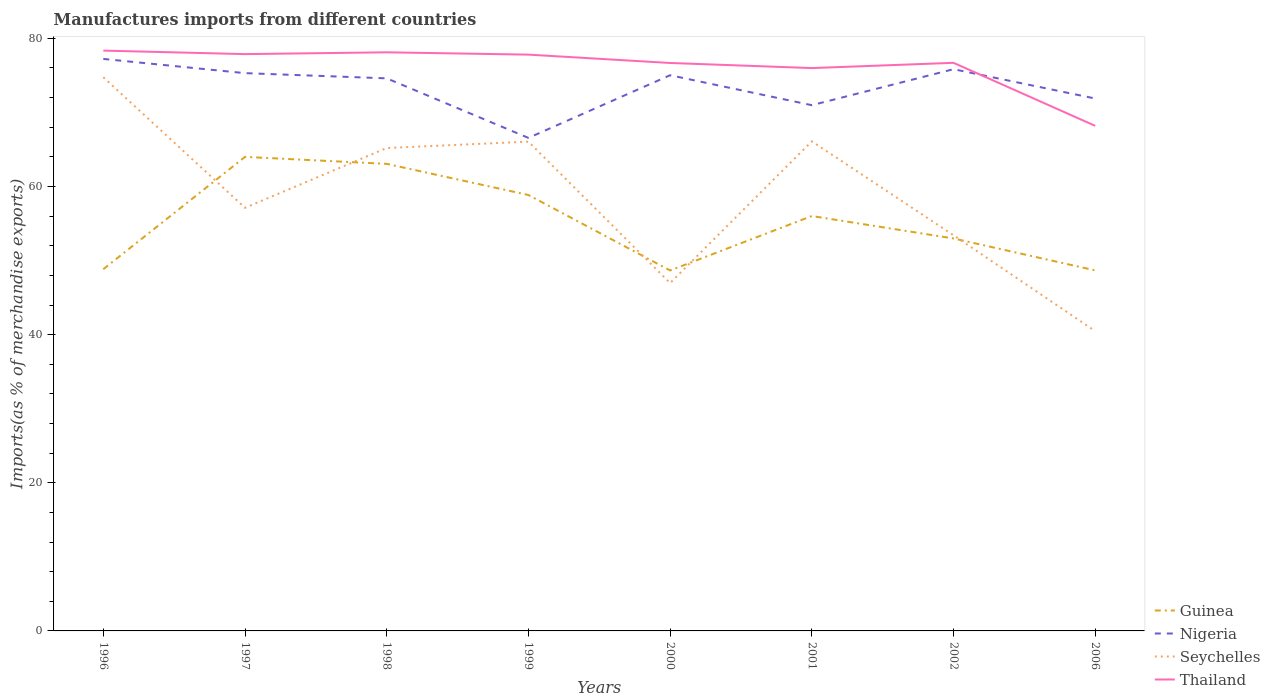How many different coloured lines are there?
Make the answer very short. 4. Does the line corresponding to Guinea intersect with the line corresponding to Thailand?
Provide a succinct answer. No. Across all years, what is the maximum percentage of imports to different countries in Nigeria?
Your answer should be very brief. 66.56. What is the total percentage of imports to different countries in Nigeria in the graph?
Provide a succinct answer. -4.86. What is the difference between the highest and the second highest percentage of imports to different countries in Nigeria?
Make the answer very short. 10.66. Is the percentage of imports to different countries in Guinea strictly greater than the percentage of imports to different countries in Nigeria over the years?
Provide a succinct answer. Yes. Does the graph contain any zero values?
Your answer should be very brief. No. Does the graph contain grids?
Your answer should be compact. No. How many legend labels are there?
Give a very brief answer. 4. What is the title of the graph?
Your answer should be compact. Manufactures imports from different countries. Does "East Asia (developing only)" appear as one of the legend labels in the graph?
Offer a terse response. No. What is the label or title of the Y-axis?
Provide a short and direct response. Imports(as % of merchandise exports). What is the Imports(as % of merchandise exports) in Guinea in 1996?
Make the answer very short. 48.83. What is the Imports(as % of merchandise exports) of Nigeria in 1996?
Your answer should be compact. 77.22. What is the Imports(as % of merchandise exports) in Seychelles in 1996?
Your answer should be compact. 74.75. What is the Imports(as % of merchandise exports) of Thailand in 1996?
Offer a terse response. 78.35. What is the Imports(as % of merchandise exports) in Guinea in 1997?
Offer a terse response. 64. What is the Imports(as % of merchandise exports) of Nigeria in 1997?
Your answer should be very brief. 75.3. What is the Imports(as % of merchandise exports) of Seychelles in 1997?
Your answer should be very brief. 57.12. What is the Imports(as % of merchandise exports) in Thailand in 1997?
Offer a terse response. 77.87. What is the Imports(as % of merchandise exports) in Guinea in 1998?
Keep it short and to the point. 63.05. What is the Imports(as % of merchandise exports) in Nigeria in 1998?
Provide a succinct answer. 74.6. What is the Imports(as % of merchandise exports) in Seychelles in 1998?
Your response must be concise. 65.19. What is the Imports(as % of merchandise exports) in Thailand in 1998?
Give a very brief answer. 78.12. What is the Imports(as % of merchandise exports) in Guinea in 1999?
Your answer should be very brief. 58.85. What is the Imports(as % of merchandise exports) in Nigeria in 1999?
Provide a short and direct response. 66.56. What is the Imports(as % of merchandise exports) of Seychelles in 1999?
Offer a terse response. 66.05. What is the Imports(as % of merchandise exports) of Thailand in 1999?
Keep it short and to the point. 77.8. What is the Imports(as % of merchandise exports) in Guinea in 2000?
Give a very brief answer. 48.66. What is the Imports(as % of merchandise exports) in Nigeria in 2000?
Give a very brief answer. 75.02. What is the Imports(as % of merchandise exports) of Seychelles in 2000?
Keep it short and to the point. 46.97. What is the Imports(as % of merchandise exports) in Thailand in 2000?
Your answer should be compact. 76.68. What is the Imports(as % of merchandise exports) in Guinea in 2001?
Keep it short and to the point. 56.01. What is the Imports(as % of merchandise exports) in Nigeria in 2001?
Make the answer very short. 70.98. What is the Imports(as % of merchandise exports) in Seychelles in 2001?
Your answer should be compact. 66.1. What is the Imports(as % of merchandise exports) of Thailand in 2001?
Make the answer very short. 75.99. What is the Imports(as % of merchandise exports) in Guinea in 2002?
Keep it short and to the point. 52.98. What is the Imports(as % of merchandise exports) of Nigeria in 2002?
Offer a very short reply. 75.84. What is the Imports(as % of merchandise exports) in Seychelles in 2002?
Make the answer very short. 53.42. What is the Imports(as % of merchandise exports) of Thailand in 2002?
Make the answer very short. 76.7. What is the Imports(as % of merchandise exports) of Guinea in 2006?
Offer a very short reply. 48.67. What is the Imports(as % of merchandise exports) of Nigeria in 2006?
Provide a short and direct response. 71.88. What is the Imports(as % of merchandise exports) of Seychelles in 2006?
Your answer should be very brief. 40.47. What is the Imports(as % of merchandise exports) in Thailand in 2006?
Offer a terse response. 68.19. Across all years, what is the maximum Imports(as % of merchandise exports) in Guinea?
Make the answer very short. 64. Across all years, what is the maximum Imports(as % of merchandise exports) of Nigeria?
Ensure brevity in your answer.  77.22. Across all years, what is the maximum Imports(as % of merchandise exports) in Seychelles?
Give a very brief answer. 74.75. Across all years, what is the maximum Imports(as % of merchandise exports) of Thailand?
Offer a terse response. 78.35. Across all years, what is the minimum Imports(as % of merchandise exports) in Guinea?
Provide a short and direct response. 48.66. Across all years, what is the minimum Imports(as % of merchandise exports) of Nigeria?
Make the answer very short. 66.56. Across all years, what is the minimum Imports(as % of merchandise exports) in Seychelles?
Your answer should be compact. 40.47. Across all years, what is the minimum Imports(as % of merchandise exports) in Thailand?
Provide a succinct answer. 68.19. What is the total Imports(as % of merchandise exports) in Guinea in the graph?
Provide a succinct answer. 441.07. What is the total Imports(as % of merchandise exports) in Nigeria in the graph?
Your response must be concise. 587.4. What is the total Imports(as % of merchandise exports) in Seychelles in the graph?
Keep it short and to the point. 470.07. What is the total Imports(as % of merchandise exports) in Thailand in the graph?
Provide a succinct answer. 609.68. What is the difference between the Imports(as % of merchandise exports) of Guinea in 1996 and that in 1997?
Keep it short and to the point. -15.17. What is the difference between the Imports(as % of merchandise exports) of Nigeria in 1996 and that in 1997?
Give a very brief answer. 1.92. What is the difference between the Imports(as % of merchandise exports) in Seychelles in 1996 and that in 1997?
Offer a very short reply. 17.63. What is the difference between the Imports(as % of merchandise exports) in Thailand in 1996 and that in 1997?
Your answer should be very brief. 0.47. What is the difference between the Imports(as % of merchandise exports) in Guinea in 1996 and that in 1998?
Provide a short and direct response. -14.22. What is the difference between the Imports(as % of merchandise exports) in Nigeria in 1996 and that in 1998?
Give a very brief answer. 2.62. What is the difference between the Imports(as % of merchandise exports) of Seychelles in 1996 and that in 1998?
Offer a terse response. 9.55. What is the difference between the Imports(as % of merchandise exports) in Thailand in 1996 and that in 1998?
Offer a terse response. 0.23. What is the difference between the Imports(as % of merchandise exports) of Guinea in 1996 and that in 1999?
Your answer should be very brief. -10.02. What is the difference between the Imports(as % of merchandise exports) of Nigeria in 1996 and that in 1999?
Keep it short and to the point. 10.66. What is the difference between the Imports(as % of merchandise exports) in Seychelles in 1996 and that in 1999?
Ensure brevity in your answer.  8.7. What is the difference between the Imports(as % of merchandise exports) of Thailand in 1996 and that in 1999?
Your answer should be compact. 0.54. What is the difference between the Imports(as % of merchandise exports) in Guinea in 1996 and that in 2000?
Your answer should be compact. 0.17. What is the difference between the Imports(as % of merchandise exports) of Nigeria in 1996 and that in 2000?
Keep it short and to the point. 2.2. What is the difference between the Imports(as % of merchandise exports) in Seychelles in 1996 and that in 2000?
Your response must be concise. 27.78. What is the difference between the Imports(as % of merchandise exports) in Thailand in 1996 and that in 2000?
Keep it short and to the point. 1.67. What is the difference between the Imports(as % of merchandise exports) of Guinea in 1996 and that in 2001?
Offer a very short reply. -7.18. What is the difference between the Imports(as % of merchandise exports) of Nigeria in 1996 and that in 2001?
Your answer should be very brief. 6.24. What is the difference between the Imports(as % of merchandise exports) in Seychelles in 1996 and that in 2001?
Give a very brief answer. 8.65. What is the difference between the Imports(as % of merchandise exports) of Thailand in 1996 and that in 2001?
Keep it short and to the point. 2.36. What is the difference between the Imports(as % of merchandise exports) in Guinea in 1996 and that in 2002?
Offer a very short reply. -4.15. What is the difference between the Imports(as % of merchandise exports) of Nigeria in 1996 and that in 2002?
Keep it short and to the point. 1.39. What is the difference between the Imports(as % of merchandise exports) in Seychelles in 1996 and that in 2002?
Keep it short and to the point. 21.33. What is the difference between the Imports(as % of merchandise exports) in Thailand in 1996 and that in 2002?
Your response must be concise. 1.65. What is the difference between the Imports(as % of merchandise exports) in Guinea in 1996 and that in 2006?
Offer a terse response. 0.16. What is the difference between the Imports(as % of merchandise exports) in Nigeria in 1996 and that in 2006?
Offer a very short reply. 5.35. What is the difference between the Imports(as % of merchandise exports) of Seychelles in 1996 and that in 2006?
Offer a very short reply. 34.28. What is the difference between the Imports(as % of merchandise exports) in Thailand in 1996 and that in 2006?
Your response must be concise. 10.16. What is the difference between the Imports(as % of merchandise exports) of Guinea in 1997 and that in 1998?
Offer a very short reply. 0.94. What is the difference between the Imports(as % of merchandise exports) of Nigeria in 1997 and that in 1998?
Keep it short and to the point. 0.7. What is the difference between the Imports(as % of merchandise exports) in Seychelles in 1997 and that in 1998?
Provide a short and direct response. -8.07. What is the difference between the Imports(as % of merchandise exports) in Thailand in 1997 and that in 1998?
Give a very brief answer. -0.24. What is the difference between the Imports(as % of merchandise exports) in Guinea in 1997 and that in 1999?
Ensure brevity in your answer.  5.15. What is the difference between the Imports(as % of merchandise exports) of Nigeria in 1997 and that in 1999?
Make the answer very short. 8.74. What is the difference between the Imports(as % of merchandise exports) in Seychelles in 1997 and that in 1999?
Offer a terse response. -8.93. What is the difference between the Imports(as % of merchandise exports) of Thailand in 1997 and that in 1999?
Your answer should be compact. 0.07. What is the difference between the Imports(as % of merchandise exports) in Guinea in 1997 and that in 2000?
Offer a very short reply. 15.34. What is the difference between the Imports(as % of merchandise exports) of Nigeria in 1997 and that in 2000?
Your answer should be very brief. 0.28. What is the difference between the Imports(as % of merchandise exports) in Seychelles in 1997 and that in 2000?
Your response must be concise. 10.16. What is the difference between the Imports(as % of merchandise exports) of Thailand in 1997 and that in 2000?
Your response must be concise. 1.2. What is the difference between the Imports(as % of merchandise exports) in Guinea in 1997 and that in 2001?
Provide a succinct answer. 7.99. What is the difference between the Imports(as % of merchandise exports) of Nigeria in 1997 and that in 2001?
Your response must be concise. 4.32. What is the difference between the Imports(as % of merchandise exports) of Seychelles in 1997 and that in 2001?
Ensure brevity in your answer.  -8.97. What is the difference between the Imports(as % of merchandise exports) of Thailand in 1997 and that in 2001?
Ensure brevity in your answer.  1.89. What is the difference between the Imports(as % of merchandise exports) in Guinea in 1997 and that in 2002?
Keep it short and to the point. 11.01. What is the difference between the Imports(as % of merchandise exports) of Nigeria in 1997 and that in 2002?
Your answer should be very brief. -0.53. What is the difference between the Imports(as % of merchandise exports) in Seychelles in 1997 and that in 2002?
Ensure brevity in your answer.  3.71. What is the difference between the Imports(as % of merchandise exports) of Thailand in 1997 and that in 2002?
Offer a very short reply. 1.18. What is the difference between the Imports(as % of merchandise exports) in Guinea in 1997 and that in 2006?
Keep it short and to the point. 15.33. What is the difference between the Imports(as % of merchandise exports) of Nigeria in 1997 and that in 2006?
Your response must be concise. 3.43. What is the difference between the Imports(as % of merchandise exports) in Seychelles in 1997 and that in 2006?
Provide a succinct answer. 16.65. What is the difference between the Imports(as % of merchandise exports) in Thailand in 1997 and that in 2006?
Make the answer very short. 9.69. What is the difference between the Imports(as % of merchandise exports) of Guinea in 1998 and that in 1999?
Offer a terse response. 4.2. What is the difference between the Imports(as % of merchandise exports) in Nigeria in 1998 and that in 1999?
Your response must be concise. 8.04. What is the difference between the Imports(as % of merchandise exports) of Seychelles in 1998 and that in 1999?
Offer a very short reply. -0.86. What is the difference between the Imports(as % of merchandise exports) in Thailand in 1998 and that in 1999?
Give a very brief answer. 0.31. What is the difference between the Imports(as % of merchandise exports) in Guinea in 1998 and that in 2000?
Your response must be concise. 14.39. What is the difference between the Imports(as % of merchandise exports) of Nigeria in 1998 and that in 2000?
Your response must be concise. -0.42. What is the difference between the Imports(as % of merchandise exports) in Seychelles in 1998 and that in 2000?
Ensure brevity in your answer.  18.23. What is the difference between the Imports(as % of merchandise exports) of Thailand in 1998 and that in 2000?
Offer a very short reply. 1.44. What is the difference between the Imports(as % of merchandise exports) of Guinea in 1998 and that in 2001?
Your answer should be compact. 7.04. What is the difference between the Imports(as % of merchandise exports) of Nigeria in 1998 and that in 2001?
Offer a very short reply. 3.62. What is the difference between the Imports(as % of merchandise exports) of Seychelles in 1998 and that in 2001?
Give a very brief answer. -0.9. What is the difference between the Imports(as % of merchandise exports) in Thailand in 1998 and that in 2001?
Provide a short and direct response. 2.13. What is the difference between the Imports(as % of merchandise exports) of Guinea in 1998 and that in 2002?
Provide a short and direct response. 10.07. What is the difference between the Imports(as % of merchandise exports) in Nigeria in 1998 and that in 2002?
Provide a short and direct response. -1.24. What is the difference between the Imports(as % of merchandise exports) in Seychelles in 1998 and that in 2002?
Ensure brevity in your answer.  11.78. What is the difference between the Imports(as % of merchandise exports) of Thailand in 1998 and that in 2002?
Give a very brief answer. 1.42. What is the difference between the Imports(as % of merchandise exports) of Guinea in 1998 and that in 2006?
Provide a succinct answer. 14.38. What is the difference between the Imports(as % of merchandise exports) of Nigeria in 1998 and that in 2006?
Offer a terse response. 2.72. What is the difference between the Imports(as % of merchandise exports) in Seychelles in 1998 and that in 2006?
Your answer should be very brief. 24.72. What is the difference between the Imports(as % of merchandise exports) of Thailand in 1998 and that in 2006?
Provide a succinct answer. 9.93. What is the difference between the Imports(as % of merchandise exports) of Guinea in 1999 and that in 2000?
Give a very brief answer. 10.19. What is the difference between the Imports(as % of merchandise exports) of Nigeria in 1999 and that in 2000?
Offer a very short reply. -8.46. What is the difference between the Imports(as % of merchandise exports) of Seychelles in 1999 and that in 2000?
Offer a terse response. 19.09. What is the difference between the Imports(as % of merchandise exports) in Thailand in 1999 and that in 2000?
Make the answer very short. 1.13. What is the difference between the Imports(as % of merchandise exports) in Guinea in 1999 and that in 2001?
Your response must be concise. 2.84. What is the difference between the Imports(as % of merchandise exports) in Nigeria in 1999 and that in 2001?
Keep it short and to the point. -4.42. What is the difference between the Imports(as % of merchandise exports) in Seychelles in 1999 and that in 2001?
Provide a short and direct response. -0.04. What is the difference between the Imports(as % of merchandise exports) in Thailand in 1999 and that in 2001?
Ensure brevity in your answer.  1.82. What is the difference between the Imports(as % of merchandise exports) of Guinea in 1999 and that in 2002?
Ensure brevity in your answer.  5.87. What is the difference between the Imports(as % of merchandise exports) in Nigeria in 1999 and that in 2002?
Your answer should be very brief. -9.28. What is the difference between the Imports(as % of merchandise exports) of Seychelles in 1999 and that in 2002?
Your answer should be compact. 12.64. What is the difference between the Imports(as % of merchandise exports) of Thailand in 1999 and that in 2002?
Provide a short and direct response. 1.11. What is the difference between the Imports(as % of merchandise exports) of Guinea in 1999 and that in 2006?
Your answer should be very brief. 10.18. What is the difference between the Imports(as % of merchandise exports) of Nigeria in 1999 and that in 2006?
Offer a very short reply. -5.32. What is the difference between the Imports(as % of merchandise exports) of Seychelles in 1999 and that in 2006?
Give a very brief answer. 25.58. What is the difference between the Imports(as % of merchandise exports) of Thailand in 1999 and that in 2006?
Your answer should be very brief. 9.62. What is the difference between the Imports(as % of merchandise exports) in Guinea in 2000 and that in 2001?
Provide a short and direct response. -7.35. What is the difference between the Imports(as % of merchandise exports) in Nigeria in 2000 and that in 2001?
Your answer should be compact. 4.04. What is the difference between the Imports(as % of merchandise exports) of Seychelles in 2000 and that in 2001?
Offer a very short reply. -19.13. What is the difference between the Imports(as % of merchandise exports) of Thailand in 2000 and that in 2001?
Offer a terse response. 0.69. What is the difference between the Imports(as % of merchandise exports) of Guinea in 2000 and that in 2002?
Give a very brief answer. -4.32. What is the difference between the Imports(as % of merchandise exports) of Nigeria in 2000 and that in 2002?
Provide a succinct answer. -0.82. What is the difference between the Imports(as % of merchandise exports) of Seychelles in 2000 and that in 2002?
Your answer should be compact. -6.45. What is the difference between the Imports(as % of merchandise exports) of Thailand in 2000 and that in 2002?
Provide a succinct answer. -0.02. What is the difference between the Imports(as % of merchandise exports) of Guinea in 2000 and that in 2006?
Offer a terse response. -0.01. What is the difference between the Imports(as % of merchandise exports) of Nigeria in 2000 and that in 2006?
Provide a short and direct response. 3.14. What is the difference between the Imports(as % of merchandise exports) of Seychelles in 2000 and that in 2006?
Ensure brevity in your answer.  6.49. What is the difference between the Imports(as % of merchandise exports) of Thailand in 2000 and that in 2006?
Your answer should be compact. 8.49. What is the difference between the Imports(as % of merchandise exports) of Guinea in 2001 and that in 2002?
Give a very brief answer. 3.03. What is the difference between the Imports(as % of merchandise exports) of Nigeria in 2001 and that in 2002?
Ensure brevity in your answer.  -4.86. What is the difference between the Imports(as % of merchandise exports) in Seychelles in 2001 and that in 2002?
Your answer should be very brief. 12.68. What is the difference between the Imports(as % of merchandise exports) of Thailand in 2001 and that in 2002?
Make the answer very short. -0.71. What is the difference between the Imports(as % of merchandise exports) in Guinea in 2001 and that in 2006?
Provide a succinct answer. 7.34. What is the difference between the Imports(as % of merchandise exports) of Nigeria in 2001 and that in 2006?
Offer a terse response. -0.9. What is the difference between the Imports(as % of merchandise exports) in Seychelles in 2001 and that in 2006?
Make the answer very short. 25.63. What is the difference between the Imports(as % of merchandise exports) of Thailand in 2001 and that in 2006?
Offer a very short reply. 7.8. What is the difference between the Imports(as % of merchandise exports) in Guinea in 2002 and that in 2006?
Provide a succinct answer. 4.31. What is the difference between the Imports(as % of merchandise exports) of Nigeria in 2002 and that in 2006?
Ensure brevity in your answer.  3.96. What is the difference between the Imports(as % of merchandise exports) of Seychelles in 2002 and that in 2006?
Keep it short and to the point. 12.95. What is the difference between the Imports(as % of merchandise exports) in Thailand in 2002 and that in 2006?
Your response must be concise. 8.51. What is the difference between the Imports(as % of merchandise exports) of Guinea in 1996 and the Imports(as % of merchandise exports) of Nigeria in 1997?
Your response must be concise. -26.47. What is the difference between the Imports(as % of merchandise exports) of Guinea in 1996 and the Imports(as % of merchandise exports) of Seychelles in 1997?
Offer a very short reply. -8.29. What is the difference between the Imports(as % of merchandise exports) of Guinea in 1996 and the Imports(as % of merchandise exports) of Thailand in 1997?
Ensure brevity in your answer.  -29.04. What is the difference between the Imports(as % of merchandise exports) of Nigeria in 1996 and the Imports(as % of merchandise exports) of Seychelles in 1997?
Make the answer very short. 20.1. What is the difference between the Imports(as % of merchandise exports) of Nigeria in 1996 and the Imports(as % of merchandise exports) of Thailand in 1997?
Provide a short and direct response. -0.65. What is the difference between the Imports(as % of merchandise exports) of Seychelles in 1996 and the Imports(as % of merchandise exports) of Thailand in 1997?
Your answer should be very brief. -3.12. What is the difference between the Imports(as % of merchandise exports) in Guinea in 1996 and the Imports(as % of merchandise exports) in Nigeria in 1998?
Offer a terse response. -25.77. What is the difference between the Imports(as % of merchandise exports) in Guinea in 1996 and the Imports(as % of merchandise exports) in Seychelles in 1998?
Provide a short and direct response. -16.36. What is the difference between the Imports(as % of merchandise exports) in Guinea in 1996 and the Imports(as % of merchandise exports) in Thailand in 1998?
Make the answer very short. -29.28. What is the difference between the Imports(as % of merchandise exports) in Nigeria in 1996 and the Imports(as % of merchandise exports) in Seychelles in 1998?
Keep it short and to the point. 12.03. What is the difference between the Imports(as % of merchandise exports) in Nigeria in 1996 and the Imports(as % of merchandise exports) in Thailand in 1998?
Provide a succinct answer. -0.89. What is the difference between the Imports(as % of merchandise exports) of Seychelles in 1996 and the Imports(as % of merchandise exports) of Thailand in 1998?
Your response must be concise. -3.37. What is the difference between the Imports(as % of merchandise exports) in Guinea in 1996 and the Imports(as % of merchandise exports) in Nigeria in 1999?
Your answer should be compact. -17.73. What is the difference between the Imports(as % of merchandise exports) in Guinea in 1996 and the Imports(as % of merchandise exports) in Seychelles in 1999?
Offer a very short reply. -17.22. What is the difference between the Imports(as % of merchandise exports) in Guinea in 1996 and the Imports(as % of merchandise exports) in Thailand in 1999?
Your response must be concise. -28.97. What is the difference between the Imports(as % of merchandise exports) in Nigeria in 1996 and the Imports(as % of merchandise exports) in Seychelles in 1999?
Your answer should be compact. 11.17. What is the difference between the Imports(as % of merchandise exports) of Nigeria in 1996 and the Imports(as % of merchandise exports) of Thailand in 1999?
Provide a short and direct response. -0.58. What is the difference between the Imports(as % of merchandise exports) in Seychelles in 1996 and the Imports(as % of merchandise exports) in Thailand in 1999?
Provide a short and direct response. -3.05. What is the difference between the Imports(as % of merchandise exports) in Guinea in 1996 and the Imports(as % of merchandise exports) in Nigeria in 2000?
Ensure brevity in your answer.  -26.19. What is the difference between the Imports(as % of merchandise exports) in Guinea in 1996 and the Imports(as % of merchandise exports) in Seychelles in 2000?
Your response must be concise. 1.87. What is the difference between the Imports(as % of merchandise exports) of Guinea in 1996 and the Imports(as % of merchandise exports) of Thailand in 2000?
Give a very brief answer. -27.84. What is the difference between the Imports(as % of merchandise exports) in Nigeria in 1996 and the Imports(as % of merchandise exports) in Seychelles in 2000?
Provide a short and direct response. 30.26. What is the difference between the Imports(as % of merchandise exports) in Nigeria in 1996 and the Imports(as % of merchandise exports) in Thailand in 2000?
Make the answer very short. 0.55. What is the difference between the Imports(as % of merchandise exports) of Seychelles in 1996 and the Imports(as % of merchandise exports) of Thailand in 2000?
Give a very brief answer. -1.93. What is the difference between the Imports(as % of merchandise exports) in Guinea in 1996 and the Imports(as % of merchandise exports) in Nigeria in 2001?
Provide a succinct answer. -22.14. What is the difference between the Imports(as % of merchandise exports) in Guinea in 1996 and the Imports(as % of merchandise exports) in Seychelles in 2001?
Give a very brief answer. -17.26. What is the difference between the Imports(as % of merchandise exports) of Guinea in 1996 and the Imports(as % of merchandise exports) of Thailand in 2001?
Provide a short and direct response. -27.15. What is the difference between the Imports(as % of merchandise exports) of Nigeria in 1996 and the Imports(as % of merchandise exports) of Seychelles in 2001?
Your response must be concise. 11.12. What is the difference between the Imports(as % of merchandise exports) in Nigeria in 1996 and the Imports(as % of merchandise exports) in Thailand in 2001?
Your response must be concise. 1.24. What is the difference between the Imports(as % of merchandise exports) in Seychelles in 1996 and the Imports(as % of merchandise exports) in Thailand in 2001?
Provide a short and direct response. -1.24. What is the difference between the Imports(as % of merchandise exports) in Guinea in 1996 and the Imports(as % of merchandise exports) in Nigeria in 2002?
Your answer should be compact. -27. What is the difference between the Imports(as % of merchandise exports) of Guinea in 1996 and the Imports(as % of merchandise exports) of Seychelles in 2002?
Offer a terse response. -4.58. What is the difference between the Imports(as % of merchandise exports) in Guinea in 1996 and the Imports(as % of merchandise exports) in Thailand in 2002?
Ensure brevity in your answer.  -27.86. What is the difference between the Imports(as % of merchandise exports) of Nigeria in 1996 and the Imports(as % of merchandise exports) of Seychelles in 2002?
Your answer should be compact. 23.81. What is the difference between the Imports(as % of merchandise exports) of Nigeria in 1996 and the Imports(as % of merchandise exports) of Thailand in 2002?
Your answer should be compact. 0.53. What is the difference between the Imports(as % of merchandise exports) of Seychelles in 1996 and the Imports(as % of merchandise exports) of Thailand in 2002?
Give a very brief answer. -1.95. What is the difference between the Imports(as % of merchandise exports) in Guinea in 1996 and the Imports(as % of merchandise exports) in Nigeria in 2006?
Your answer should be compact. -23.04. What is the difference between the Imports(as % of merchandise exports) in Guinea in 1996 and the Imports(as % of merchandise exports) in Seychelles in 2006?
Offer a terse response. 8.36. What is the difference between the Imports(as % of merchandise exports) of Guinea in 1996 and the Imports(as % of merchandise exports) of Thailand in 2006?
Your answer should be compact. -19.35. What is the difference between the Imports(as % of merchandise exports) in Nigeria in 1996 and the Imports(as % of merchandise exports) in Seychelles in 2006?
Your answer should be compact. 36.75. What is the difference between the Imports(as % of merchandise exports) in Nigeria in 1996 and the Imports(as % of merchandise exports) in Thailand in 2006?
Your answer should be very brief. 9.04. What is the difference between the Imports(as % of merchandise exports) in Seychelles in 1996 and the Imports(as % of merchandise exports) in Thailand in 2006?
Your response must be concise. 6.56. What is the difference between the Imports(as % of merchandise exports) of Guinea in 1997 and the Imports(as % of merchandise exports) of Nigeria in 1998?
Offer a very short reply. -10.6. What is the difference between the Imports(as % of merchandise exports) of Guinea in 1997 and the Imports(as % of merchandise exports) of Seychelles in 1998?
Provide a short and direct response. -1.2. What is the difference between the Imports(as % of merchandise exports) of Guinea in 1997 and the Imports(as % of merchandise exports) of Thailand in 1998?
Your answer should be compact. -14.12. What is the difference between the Imports(as % of merchandise exports) in Nigeria in 1997 and the Imports(as % of merchandise exports) in Seychelles in 1998?
Your answer should be very brief. 10.11. What is the difference between the Imports(as % of merchandise exports) in Nigeria in 1997 and the Imports(as % of merchandise exports) in Thailand in 1998?
Your answer should be very brief. -2.81. What is the difference between the Imports(as % of merchandise exports) of Seychelles in 1997 and the Imports(as % of merchandise exports) of Thailand in 1998?
Your answer should be compact. -20.99. What is the difference between the Imports(as % of merchandise exports) in Guinea in 1997 and the Imports(as % of merchandise exports) in Nigeria in 1999?
Keep it short and to the point. -2.56. What is the difference between the Imports(as % of merchandise exports) of Guinea in 1997 and the Imports(as % of merchandise exports) of Seychelles in 1999?
Make the answer very short. -2.05. What is the difference between the Imports(as % of merchandise exports) of Guinea in 1997 and the Imports(as % of merchandise exports) of Thailand in 1999?
Ensure brevity in your answer.  -13.8. What is the difference between the Imports(as % of merchandise exports) in Nigeria in 1997 and the Imports(as % of merchandise exports) in Seychelles in 1999?
Offer a very short reply. 9.25. What is the difference between the Imports(as % of merchandise exports) of Nigeria in 1997 and the Imports(as % of merchandise exports) of Thailand in 1999?
Give a very brief answer. -2.5. What is the difference between the Imports(as % of merchandise exports) of Seychelles in 1997 and the Imports(as % of merchandise exports) of Thailand in 1999?
Provide a succinct answer. -20.68. What is the difference between the Imports(as % of merchandise exports) in Guinea in 1997 and the Imports(as % of merchandise exports) in Nigeria in 2000?
Provide a short and direct response. -11.02. What is the difference between the Imports(as % of merchandise exports) of Guinea in 1997 and the Imports(as % of merchandise exports) of Seychelles in 2000?
Your response must be concise. 17.03. What is the difference between the Imports(as % of merchandise exports) in Guinea in 1997 and the Imports(as % of merchandise exports) in Thailand in 2000?
Offer a very short reply. -12.68. What is the difference between the Imports(as % of merchandise exports) of Nigeria in 1997 and the Imports(as % of merchandise exports) of Seychelles in 2000?
Offer a very short reply. 28.34. What is the difference between the Imports(as % of merchandise exports) of Nigeria in 1997 and the Imports(as % of merchandise exports) of Thailand in 2000?
Offer a very short reply. -1.37. What is the difference between the Imports(as % of merchandise exports) in Seychelles in 1997 and the Imports(as % of merchandise exports) in Thailand in 2000?
Keep it short and to the point. -19.55. What is the difference between the Imports(as % of merchandise exports) of Guinea in 1997 and the Imports(as % of merchandise exports) of Nigeria in 2001?
Provide a short and direct response. -6.98. What is the difference between the Imports(as % of merchandise exports) of Guinea in 1997 and the Imports(as % of merchandise exports) of Seychelles in 2001?
Offer a very short reply. -2.1. What is the difference between the Imports(as % of merchandise exports) of Guinea in 1997 and the Imports(as % of merchandise exports) of Thailand in 2001?
Keep it short and to the point. -11.99. What is the difference between the Imports(as % of merchandise exports) in Nigeria in 1997 and the Imports(as % of merchandise exports) in Seychelles in 2001?
Provide a short and direct response. 9.2. What is the difference between the Imports(as % of merchandise exports) of Nigeria in 1997 and the Imports(as % of merchandise exports) of Thailand in 2001?
Make the answer very short. -0.69. What is the difference between the Imports(as % of merchandise exports) of Seychelles in 1997 and the Imports(as % of merchandise exports) of Thailand in 2001?
Make the answer very short. -18.86. What is the difference between the Imports(as % of merchandise exports) of Guinea in 1997 and the Imports(as % of merchandise exports) of Nigeria in 2002?
Make the answer very short. -11.84. What is the difference between the Imports(as % of merchandise exports) in Guinea in 1997 and the Imports(as % of merchandise exports) in Seychelles in 2002?
Your answer should be compact. 10.58. What is the difference between the Imports(as % of merchandise exports) in Guinea in 1997 and the Imports(as % of merchandise exports) in Thailand in 2002?
Offer a very short reply. -12.7. What is the difference between the Imports(as % of merchandise exports) of Nigeria in 1997 and the Imports(as % of merchandise exports) of Seychelles in 2002?
Make the answer very short. 21.89. What is the difference between the Imports(as % of merchandise exports) in Nigeria in 1997 and the Imports(as % of merchandise exports) in Thailand in 2002?
Give a very brief answer. -1.39. What is the difference between the Imports(as % of merchandise exports) of Seychelles in 1997 and the Imports(as % of merchandise exports) of Thailand in 2002?
Offer a terse response. -19.57. What is the difference between the Imports(as % of merchandise exports) in Guinea in 1997 and the Imports(as % of merchandise exports) in Nigeria in 2006?
Give a very brief answer. -7.88. What is the difference between the Imports(as % of merchandise exports) of Guinea in 1997 and the Imports(as % of merchandise exports) of Seychelles in 2006?
Your answer should be very brief. 23.53. What is the difference between the Imports(as % of merchandise exports) in Guinea in 1997 and the Imports(as % of merchandise exports) in Thailand in 2006?
Provide a short and direct response. -4.19. What is the difference between the Imports(as % of merchandise exports) in Nigeria in 1997 and the Imports(as % of merchandise exports) in Seychelles in 2006?
Your answer should be very brief. 34.83. What is the difference between the Imports(as % of merchandise exports) in Nigeria in 1997 and the Imports(as % of merchandise exports) in Thailand in 2006?
Your answer should be very brief. 7.12. What is the difference between the Imports(as % of merchandise exports) of Seychelles in 1997 and the Imports(as % of merchandise exports) of Thailand in 2006?
Offer a very short reply. -11.06. What is the difference between the Imports(as % of merchandise exports) in Guinea in 1998 and the Imports(as % of merchandise exports) in Nigeria in 1999?
Offer a very short reply. -3.51. What is the difference between the Imports(as % of merchandise exports) in Guinea in 1998 and the Imports(as % of merchandise exports) in Seychelles in 1999?
Offer a terse response. -3. What is the difference between the Imports(as % of merchandise exports) of Guinea in 1998 and the Imports(as % of merchandise exports) of Thailand in 1999?
Your answer should be compact. -14.75. What is the difference between the Imports(as % of merchandise exports) in Nigeria in 1998 and the Imports(as % of merchandise exports) in Seychelles in 1999?
Your answer should be very brief. 8.55. What is the difference between the Imports(as % of merchandise exports) of Nigeria in 1998 and the Imports(as % of merchandise exports) of Thailand in 1999?
Provide a short and direct response. -3.2. What is the difference between the Imports(as % of merchandise exports) of Seychelles in 1998 and the Imports(as % of merchandise exports) of Thailand in 1999?
Ensure brevity in your answer.  -12.61. What is the difference between the Imports(as % of merchandise exports) in Guinea in 1998 and the Imports(as % of merchandise exports) in Nigeria in 2000?
Keep it short and to the point. -11.97. What is the difference between the Imports(as % of merchandise exports) in Guinea in 1998 and the Imports(as % of merchandise exports) in Seychelles in 2000?
Offer a terse response. 16.09. What is the difference between the Imports(as % of merchandise exports) in Guinea in 1998 and the Imports(as % of merchandise exports) in Thailand in 2000?
Provide a succinct answer. -13.62. What is the difference between the Imports(as % of merchandise exports) of Nigeria in 1998 and the Imports(as % of merchandise exports) of Seychelles in 2000?
Provide a short and direct response. 27.63. What is the difference between the Imports(as % of merchandise exports) in Nigeria in 1998 and the Imports(as % of merchandise exports) in Thailand in 2000?
Provide a short and direct response. -2.08. What is the difference between the Imports(as % of merchandise exports) in Seychelles in 1998 and the Imports(as % of merchandise exports) in Thailand in 2000?
Your answer should be compact. -11.48. What is the difference between the Imports(as % of merchandise exports) in Guinea in 1998 and the Imports(as % of merchandise exports) in Nigeria in 2001?
Offer a very short reply. -7.92. What is the difference between the Imports(as % of merchandise exports) of Guinea in 1998 and the Imports(as % of merchandise exports) of Seychelles in 2001?
Your answer should be compact. -3.04. What is the difference between the Imports(as % of merchandise exports) in Guinea in 1998 and the Imports(as % of merchandise exports) in Thailand in 2001?
Offer a very short reply. -12.93. What is the difference between the Imports(as % of merchandise exports) of Nigeria in 1998 and the Imports(as % of merchandise exports) of Seychelles in 2001?
Your answer should be very brief. 8.5. What is the difference between the Imports(as % of merchandise exports) of Nigeria in 1998 and the Imports(as % of merchandise exports) of Thailand in 2001?
Make the answer very short. -1.39. What is the difference between the Imports(as % of merchandise exports) of Seychelles in 1998 and the Imports(as % of merchandise exports) of Thailand in 2001?
Offer a very short reply. -10.79. What is the difference between the Imports(as % of merchandise exports) of Guinea in 1998 and the Imports(as % of merchandise exports) of Nigeria in 2002?
Provide a succinct answer. -12.78. What is the difference between the Imports(as % of merchandise exports) in Guinea in 1998 and the Imports(as % of merchandise exports) in Seychelles in 2002?
Offer a terse response. 9.64. What is the difference between the Imports(as % of merchandise exports) in Guinea in 1998 and the Imports(as % of merchandise exports) in Thailand in 2002?
Provide a short and direct response. -13.64. What is the difference between the Imports(as % of merchandise exports) of Nigeria in 1998 and the Imports(as % of merchandise exports) of Seychelles in 2002?
Your answer should be very brief. 21.18. What is the difference between the Imports(as % of merchandise exports) of Nigeria in 1998 and the Imports(as % of merchandise exports) of Thailand in 2002?
Ensure brevity in your answer.  -2.1. What is the difference between the Imports(as % of merchandise exports) of Seychelles in 1998 and the Imports(as % of merchandise exports) of Thailand in 2002?
Offer a terse response. -11.5. What is the difference between the Imports(as % of merchandise exports) of Guinea in 1998 and the Imports(as % of merchandise exports) of Nigeria in 2006?
Provide a succinct answer. -8.82. What is the difference between the Imports(as % of merchandise exports) of Guinea in 1998 and the Imports(as % of merchandise exports) of Seychelles in 2006?
Your response must be concise. 22.58. What is the difference between the Imports(as % of merchandise exports) of Guinea in 1998 and the Imports(as % of merchandise exports) of Thailand in 2006?
Provide a short and direct response. -5.13. What is the difference between the Imports(as % of merchandise exports) in Nigeria in 1998 and the Imports(as % of merchandise exports) in Seychelles in 2006?
Provide a short and direct response. 34.13. What is the difference between the Imports(as % of merchandise exports) of Nigeria in 1998 and the Imports(as % of merchandise exports) of Thailand in 2006?
Offer a terse response. 6.41. What is the difference between the Imports(as % of merchandise exports) of Seychelles in 1998 and the Imports(as % of merchandise exports) of Thailand in 2006?
Provide a succinct answer. -2.99. What is the difference between the Imports(as % of merchandise exports) of Guinea in 1999 and the Imports(as % of merchandise exports) of Nigeria in 2000?
Your answer should be compact. -16.17. What is the difference between the Imports(as % of merchandise exports) in Guinea in 1999 and the Imports(as % of merchandise exports) in Seychelles in 2000?
Offer a very short reply. 11.89. What is the difference between the Imports(as % of merchandise exports) in Guinea in 1999 and the Imports(as % of merchandise exports) in Thailand in 2000?
Your response must be concise. -17.82. What is the difference between the Imports(as % of merchandise exports) in Nigeria in 1999 and the Imports(as % of merchandise exports) in Seychelles in 2000?
Give a very brief answer. 19.6. What is the difference between the Imports(as % of merchandise exports) in Nigeria in 1999 and the Imports(as % of merchandise exports) in Thailand in 2000?
Offer a very short reply. -10.11. What is the difference between the Imports(as % of merchandise exports) of Seychelles in 1999 and the Imports(as % of merchandise exports) of Thailand in 2000?
Your answer should be compact. -10.62. What is the difference between the Imports(as % of merchandise exports) in Guinea in 1999 and the Imports(as % of merchandise exports) in Nigeria in 2001?
Offer a very short reply. -12.13. What is the difference between the Imports(as % of merchandise exports) of Guinea in 1999 and the Imports(as % of merchandise exports) of Seychelles in 2001?
Make the answer very short. -7.25. What is the difference between the Imports(as % of merchandise exports) in Guinea in 1999 and the Imports(as % of merchandise exports) in Thailand in 2001?
Your response must be concise. -17.14. What is the difference between the Imports(as % of merchandise exports) in Nigeria in 1999 and the Imports(as % of merchandise exports) in Seychelles in 2001?
Give a very brief answer. 0.46. What is the difference between the Imports(as % of merchandise exports) in Nigeria in 1999 and the Imports(as % of merchandise exports) in Thailand in 2001?
Make the answer very short. -9.43. What is the difference between the Imports(as % of merchandise exports) of Seychelles in 1999 and the Imports(as % of merchandise exports) of Thailand in 2001?
Provide a succinct answer. -9.93. What is the difference between the Imports(as % of merchandise exports) of Guinea in 1999 and the Imports(as % of merchandise exports) of Nigeria in 2002?
Ensure brevity in your answer.  -16.99. What is the difference between the Imports(as % of merchandise exports) in Guinea in 1999 and the Imports(as % of merchandise exports) in Seychelles in 2002?
Give a very brief answer. 5.43. What is the difference between the Imports(as % of merchandise exports) in Guinea in 1999 and the Imports(as % of merchandise exports) in Thailand in 2002?
Your response must be concise. -17.84. What is the difference between the Imports(as % of merchandise exports) of Nigeria in 1999 and the Imports(as % of merchandise exports) of Seychelles in 2002?
Your response must be concise. 13.14. What is the difference between the Imports(as % of merchandise exports) in Nigeria in 1999 and the Imports(as % of merchandise exports) in Thailand in 2002?
Your answer should be compact. -10.13. What is the difference between the Imports(as % of merchandise exports) of Seychelles in 1999 and the Imports(as % of merchandise exports) of Thailand in 2002?
Your answer should be very brief. -10.64. What is the difference between the Imports(as % of merchandise exports) in Guinea in 1999 and the Imports(as % of merchandise exports) in Nigeria in 2006?
Make the answer very short. -13.03. What is the difference between the Imports(as % of merchandise exports) in Guinea in 1999 and the Imports(as % of merchandise exports) in Seychelles in 2006?
Ensure brevity in your answer.  18.38. What is the difference between the Imports(as % of merchandise exports) of Guinea in 1999 and the Imports(as % of merchandise exports) of Thailand in 2006?
Your answer should be very brief. -9.34. What is the difference between the Imports(as % of merchandise exports) in Nigeria in 1999 and the Imports(as % of merchandise exports) in Seychelles in 2006?
Keep it short and to the point. 26.09. What is the difference between the Imports(as % of merchandise exports) of Nigeria in 1999 and the Imports(as % of merchandise exports) of Thailand in 2006?
Ensure brevity in your answer.  -1.62. What is the difference between the Imports(as % of merchandise exports) of Seychelles in 1999 and the Imports(as % of merchandise exports) of Thailand in 2006?
Provide a short and direct response. -2.13. What is the difference between the Imports(as % of merchandise exports) of Guinea in 2000 and the Imports(as % of merchandise exports) of Nigeria in 2001?
Make the answer very short. -22.31. What is the difference between the Imports(as % of merchandise exports) of Guinea in 2000 and the Imports(as % of merchandise exports) of Seychelles in 2001?
Make the answer very short. -17.43. What is the difference between the Imports(as % of merchandise exports) of Guinea in 2000 and the Imports(as % of merchandise exports) of Thailand in 2001?
Provide a short and direct response. -27.32. What is the difference between the Imports(as % of merchandise exports) of Nigeria in 2000 and the Imports(as % of merchandise exports) of Seychelles in 2001?
Your response must be concise. 8.92. What is the difference between the Imports(as % of merchandise exports) in Nigeria in 2000 and the Imports(as % of merchandise exports) in Thailand in 2001?
Your response must be concise. -0.97. What is the difference between the Imports(as % of merchandise exports) in Seychelles in 2000 and the Imports(as % of merchandise exports) in Thailand in 2001?
Your answer should be very brief. -29.02. What is the difference between the Imports(as % of merchandise exports) in Guinea in 2000 and the Imports(as % of merchandise exports) in Nigeria in 2002?
Offer a terse response. -27.17. What is the difference between the Imports(as % of merchandise exports) of Guinea in 2000 and the Imports(as % of merchandise exports) of Seychelles in 2002?
Your answer should be compact. -4.75. What is the difference between the Imports(as % of merchandise exports) of Guinea in 2000 and the Imports(as % of merchandise exports) of Thailand in 2002?
Give a very brief answer. -28.03. What is the difference between the Imports(as % of merchandise exports) of Nigeria in 2000 and the Imports(as % of merchandise exports) of Seychelles in 2002?
Your answer should be very brief. 21.6. What is the difference between the Imports(as % of merchandise exports) of Nigeria in 2000 and the Imports(as % of merchandise exports) of Thailand in 2002?
Provide a succinct answer. -1.68. What is the difference between the Imports(as % of merchandise exports) in Seychelles in 2000 and the Imports(as % of merchandise exports) in Thailand in 2002?
Offer a very short reply. -29.73. What is the difference between the Imports(as % of merchandise exports) in Guinea in 2000 and the Imports(as % of merchandise exports) in Nigeria in 2006?
Ensure brevity in your answer.  -23.21. What is the difference between the Imports(as % of merchandise exports) of Guinea in 2000 and the Imports(as % of merchandise exports) of Seychelles in 2006?
Your answer should be very brief. 8.19. What is the difference between the Imports(as % of merchandise exports) in Guinea in 2000 and the Imports(as % of merchandise exports) in Thailand in 2006?
Ensure brevity in your answer.  -19.52. What is the difference between the Imports(as % of merchandise exports) in Nigeria in 2000 and the Imports(as % of merchandise exports) in Seychelles in 2006?
Offer a very short reply. 34.55. What is the difference between the Imports(as % of merchandise exports) of Nigeria in 2000 and the Imports(as % of merchandise exports) of Thailand in 2006?
Ensure brevity in your answer.  6.83. What is the difference between the Imports(as % of merchandise exports) in Seychelles in 2000 and the Imports(as % of merchandise exports) in Thailand in 2006?
Keep it short and to the point. -21.22. What is the difference between the Imports(as % of merchandise exports) in Guinea in 2001 and the Imports(as % of merchandise exports) in Nigeria in 2002?
Provide a succinct answer. -19.82. What is the difference between the Imports(as % of merchandise exports) in Guinea in 2001 and the Imports(as % of merchandise exports) in Seychelles in 2002?
Provide a succinct answer. 2.6. What is the difference between the Imports(as % of merchandise exports) of Guinea in 2001 and the Imports(as % of merchandise exports) of Thailand in 2002?
Keep it short and to the point. -20.68. What is the difference between the Imports(as % of merchandise exports) of Nigeria in 2001 and the Imports(as % of merchandise exports) of Seychelles in 2002?
Give a very brief answer. 17.56. What is the difference between the Imports(as % of merchandise exports) of Nigeria in 2001 and the Imports(as % of merchandise exports) of Thailand in 2002?
Keep it short and to the point. -5.72. What is the difference between the Imports(as % of merchandise exports) in Seychelles in 2001 and the Imports(as % of merchandise exports) in Thailand in 2002?
Your response must be concise. -10.6. What is the difference between the Imports(as % of merchandise exports) of Guinea in 2001 and the Imports(as % of merchandise exports) of Nigeria in 2006?
Give a very brief answer. -15.86. What is the difference between the Imports(as % of merchandise exports) of Guinea in 2001 and the Imports(as % of merchandise exports) of Seychelles in 2006?
Ensure brevity in your answer.  15.54. What is the difference between the Imports(as % of merchandise exports) in Guinea in 2001 and the Imports(as % of merchandise exports) in Thailand in 2006?
Give a very brief answer. -12.17. What is the difference between the Imports(as % of merchandise exports) of Nigeria in 2001 and the Imports(as % of merchandise exports) of Seychelles in 2006?
Offer a terse response. 30.51. What is the difference between the Imports(as % of merchandise exports) in Nigeria in 2001 and the Imports(as % of merchandise exports) in Thailand in 2006?
Provide a succinct answer. 2.79. What is the difference between the Imports(as % of merchandise exports) of Seychelles in 2001 and the Imports(as % of merchandise exports) of Thailand in 2006?
Your answer should be very brief. -2.09. What is the difference between the Imports(as % of merchandise exports) in Guinea in 2002 and the Imports(as % of merchandise exports) in Nigeria in 2006?
Keep it short and to the point. -18.89. What is the difference between the Imports(as % of merchandise exports) of Guinea in 2002 and the Imports(as % of merchandise exports) of Seychelles in 2006?
Your answer should be very brief. 12.51. What is the difference between the Imports(as % of merchandise exports) in Guinea in 2002 and the Imports(as % of merchandise exports) in Thailand in 2006?
Make the answer very short. -15.2. What is the difference between the Imports(as % of merchandise exports) of Nigeria in 2002 and the Imports(as % of merchandise exports) of Seychelles in 2006?
Give a very brief answer. 35.37. What is the difference between the Imports(as % of merchandise exports) in Nigeria in 2002 and the Imports(as % of merchandise exports) in Thailand in 2006?
Offer a terse response. 7.65. What is the difference between the Imports(as % of merchandise exports) of Seychelles in 2002 and the Imports(as % of merchandise exports) of Thailand in 2006?
Your response must be concise. -14.77. What is the average Imports(as % of merchandise exports) of Guinea per year?
Provide a short and direct response. 55.13. What is the average Imports(as % of merchandise exports) in Nigeria per year?
Offer a very short reply. 73.42. What is the average Imports(as % of merchandise exports) of Seychelles per year?
Provide a succinct answer. 58.76. What is the average Imports(as % of merchandise exports) of Thailand per year?
Your answer should be compact. 76.21. In the year 1996, what is the difference between the Imports(as % of merchandise exports) in Guinea and Imports(as % of merchandise exports) in Nigeria?
Provide a succinct answer. -28.39. In the year 1996, what is the difference between the Imports(as % of merchandise exports) in Guinea and Imports(as % of merchandise exports) in Seychelles?
Offer a terse response. -25.92. In the year 1996, what is the difference between the Imports(as % of merchandise exports) of Guinea and Imports(as % of merchandise exports) of Thailand?
Provide a short and direct response. -29.51. In the year 1996, what is the difference between the Imports(as % of merchandise exports) in Nigeria and Imports(as % of merchandise exports) in Seychelles?
Offer a very short reply. 2.47. In the year 1996, what is the difference between the Imports(as % of merchandise exports) in Nigeria and Imports(as % of merchandise exports) in Thailand?
Your answer should be compact. -1.12. In the year 1996, what is the difference between the Imports(as % of merchandise exports) in Seychelles and Imports(as % of merchandise exports) in Thailand?
Make the answer very short. -3.6. In the year 1997, what is the difference between the Imports(as % of merchandise exports) of Guinea and Imports(as % of merchandise exports) of Nigeria?
Ensure brevity in your answer.  -11.3. In the year 1997, what is the difference between the Imports(as % of merchandise exports) of Guinea and Imports(as % of merchandise exports) of Seychelles?
Provide a short and direct response. 6.88. In the year 1997, what is the difference between the Imports(as % of merchandise exports) in Guinea and Imports(as % of merchandise exports) in Thailand?
Ensure brevity in your answer.  -13.87. In the year 1997, what is the difference between the Imports(as % of merchandise exports) in Nigeria and Imports(as % of merchandise exports) in Seychelles?
Give a very brief answer. 18.18. In the year 1997, what is the difference between the Imports(as % of merchandise exports) in Nigeria and Imports(as % of merchandise exports) in Thailand?
Provide a succinct answer. -2.57. In the year 1997, what is the difference between the Imports(as % of merchandise exports) in Seychelles and Imports(as % of merchandise exports) in Thailand?
Provide a short and direct response. -20.75. In the year 1998, what is the difference between the Imports(as % of merchandise exports) in Guinea and Imports(as % of merchandise exports) in Nigeria?
Provide a short and direct response. -11.55. In the year 1998, what is the difference between the Imports(as % of merchandise exports) in Guinea and Imports(as % of merchandise exports) in Seychelles?
Provide a succinct answer. -2.14. In the year 1998, what is the difference between the Imports(as % of merchandise exports) of Guinea and Imports(as % of merchandise exports) of Thailand?
Make the answer very short. -15.06. In the year 1998, what is the difference between the Imports(as % of merchandise exports) of Nigeria and Imports(as % of merchandise exports) of Seychelles?
Your response must be concise. 9.41. In the year 1998, what is the difference between the Imports(as % of merchandise exports) of Nigeria and Imports(as % of merchandise exports) of Thailand?
Your answer should be compact. -3.52. In the year 1998, what is the difference between the Imports(as % of merchandise exports) of Seychelles and Imports(as % of merchandise exports) of Thailand?
Offer a terse response. -12.92. In the year 1999, what is the difference between the Imports(as % of merchandise exports) of Guinea and Imports(as % of merchandise exports) of Nigeria?
Make the answer very short. -7.71. In the year 1999, what is the difference between the Imports(as % of merchandise exports) of Guinea and Imports(as % of merchandise exports) of Seychelles?
Offer a terse response. -7.2. In the year 1999, what is the difference between the Imports(as % of merchandise exports) of Guinea and Imports(as % of merchandise exports) of Thailand?
Your response must be concise. -18.95. In the year 1999, what is the difference between the Imports(as % of merchandise exports) of Nigeria and Imports(as % of merchandise exports) of Seychelles?
Your response must be concise. 0.51. In the year 1999, what is the difference between the Imports(as % of merchandise exports) in Nigeria and Imports(as % of merchandise exports) in Thailand?
Your answer should be compact. -11.24. In the year 1999, what is the difference between the Imports(as % of merchandise exports) in Seychelles and Imports(as % of merchandise exports) in Thailand?
Offer a terse response. -11.75. In the year 2000, what is the difference between the Imports(as % of merchandise exports) of Guinea and Imports(as % of merchandise exports) of Nigeria?
Make the answer very short. -26.36. In the year 2000, what is the difference between the Imports(as % of merchandise exports) of Guinea and Imports(as % of merchandise exports) of Seychelles?
Give a very brief answer. 1.7. In the year 2000, what is the difference between the Imports(as % of merchandise exports) of Guinea and Imports(as % of merchandise exports) of Thailand?
Provide a short and direct response. -28.01. In the year 2000, what is the difference between the Imports(as % of merchandise exports) of Nigeria and Imports(as % of merchandise exports) of Seychelles?
Keep it short and to the point. 28.05. In the year 2000, what is the difference between the Imports(as % of merchandise exports) of Nigeria and Imports(as % of merchandise exports) of Thailand?
Make the answer very short. -1.66. In the year 2000, what is the difference between the Imports(as % of merchandise exports) in Seychelles and Imports(as % of merchandise exports) in Thailand?
Your answer should be very brief. -29.71. In the year 2001, what is the difference between the Imports(as % of merchandise exports) in Guinea and Imports(as % of merchandise exports) in Nigeria?
Offer a very short reply. -14.97. In the year 2001, what is the difference between the Imports(as % of merchandise exports) of Guinea and Imports(as % of merchandise exports) of Seychelles?
Keep it short and to the point. -10.09. In the year 2001, what is the difference between the Imports(as % of merchandise exports) in Guinea and Imports(as % of merchandise exports) in Thailand?
Provide a short and direct response. -19.97. In the year 2001, what is the difference between the Imports(as % of merchandise exports) in Nigeria and Imports(as % of merchandise exports) in Seychelles?
Provide a succinct answer. 4.88. In the year 2001, what is the difference between the Imports(as % of merchandise exports) in Nigeria and Imports(as % of merchandise exports) in Thailand?
Offer a terse response. -5.01. In the year 2001, what is the difference between the Imports(as % of merchandise exports) in Seychelles and Imports(as % of merchandise exports) in Thailand?
Provide a short and direct response. -9.89. In the year 2002, what is the difference between the Imports(as % of merchandise exports) in Guinea and Imports(as % of merchandise exports) in Nigeria?
Your answer should be compact. -22.85. In the year 2002, what is the difference between the Imports(as % of merchandise exports) of Guinea and Imports(as % of merchandise exports) of Seychelles?
Keep it short and to the point. -0.43. In the year 2002, what is the difference between the Imports(as % of merchandise exports) of Guinea and Imports(as % of merchandise exports) of Thailand?
Make the answer very short. -23.71. In the year 2002, what is the difference between the Imports(as % of merchandise exports) of Nigeria and Imports(as % of merchandise exports) of Seychelles?
Give a very brief answer. 22.42. In the year 2002, what is the difference between the Imports(as % of merchandise exports) of Nigeria and Imports(as % of merchandise exports) of Thailand?
Ensure brevity in your answer.  -0.86. In the year 2002, what is the difference between the Imports(as % of merchandise exports) in Seychelles and Imports(as % of merchandise exports) in Thailand?
Keep it short and to the point. -23.28. In the year 2006, what is the difference between the Imports(as % of merchandise exports) of Guinea and Imports(as % of merchandise exports) of Nigeria?
Provide a short and direct response. -23.2. In the year 2006, what is the difference between the Imports(as % of merchandise exports) in Guinea and Imports(as % of merchandise exports) in Seychelles?
Give a very brief answer. 8.2. In the year 2006, what is the difference between the Imports(as % of merchandise exports) of Guinea and Imports(as % of merchandise exports) of Thailand?
Offer a very short reply. -19.51. In the year 2006, what is the difference between the Imports(as % of merchandise exports) of Nigeria and Imports(as % of merchandise exports) of Seychelles?
Give a very brief answer. 31.41. In the year 2006, what is the difference between the Imports(as % of merchandise exports) in Nigeria and Imports(as % of merchandise exports) in Thailand?
Your response must be concise. 3.69. In the year 2006, what is the difference between the Imports(as % of merchandise exports) of Seychelles and Imports(as % of merchandise exports) of Thailand?
Offer a terse response. -27.71. What is the ratio of the Imports(as % of merchandise exports) of Guinea in 1996 to that in 1997?
Ensure brevity in your answer.  0.76. What is the ratio of the Imports(as % of merchandise exports) in Nigeria in 1996 to that in 1997?
Give a very brief answer. 1.03. What is the ratio of the Imports(as % of merchandise exports) in Seychelles in 1996 to that in 1997?
Your answer should be compact. 1.31. What is the ratio of the Imports(as % of merchandise exports) of Guinea in 1996 to that in 1998?
Offer a very short reply. 0.77. What is the ratio of the Imports(as % of merchandise exports) in Nigeria in 1996 to that in 1998?
Offer a very short reply. 1.04. What is the ratio of the Imports(as % of merchandise exports) of Seychelles in 1996 to that in 1998?
Give a very brief answer. 1.15. What is the ratio of the Imports(as % of merchandise exports) of Guinea in 1996 to that in 1999?
Your answer should be compact. 0.83. What is the ratio of the Imports(as % of merchandise exports) of Nigeria in 1996 to that in 1999?
Provide a short and direct response. 1.16. What is the ratio of the Imports(as % of merchandise exports) in Seychelles in 1996 to that in 1999?
Offer a terse response. 1.13. What is the ratio of the Imports(as % of merchandise exports) of Guinea in 1996 to that in 2000?
Provide a short and direct response. 1. What is the ratio of the Imports(as % of merchandise exports) of Nigeria in 1996 to that in 2000?
Offer a very short reply. 1.03. What is the ratio of the Imports(as % of merchandise exports) in Seychelles in 1996 to that in 2000?
Make the answer very short. 1.59. What is the ratio of the Imports(as % of merchandise exports) in Thailand in 1996 to that in 2000?
Give a very brief answer. 1.02. What is the ratio of the Imports(as % of merchandise exports) of Guinea in 1996 to that in 2001?
Provide a succinct answer. 0.87. What is the ratio of the Imports(as % of merchandise exports) in Nigeria in 1996 to that in 2001?
Your response must be concise. 1.09. What is the ratio of the Imports(as % of merchandise exports) of Seychelles in 1996 to that in 2001?
Your answer should be compact. 1.13. What is the ratio of the Imports(as % of merchandise exports) of Thailand in 1996 to that in 2001?
Offer a terse response. 1.03. What is the ratio of the Imports(as % of merchandise exports) of Guinea in 1996 to that in 2002?
Provide a succinct answer. 0.92. What is the ratio of the Imports(as % of merchandise exports) in Nigeria in 1996 to that in 2002?
Provide a succinct answer. 1.02. What is the ratio of the Imports(as % of merchandise exports) in Seychelles in 1996 to that in 2002?
Give a very brief answer. 1.4. What is the ratio of the Imports(as % of merchandise exports) in Thailand in 1996 to that in 2002?
Provide a succinct answer. 1.02. What is the ratio of the Imports(as % of merchandise exports) in Nigeria in 1996 to that in 2006?
Make the answer very short. 1.07. What is the ratio of the Imports(as % of merchandise exports) of Seychelles in 1996 to that in 2006?
Give a very brief answer. 1.85. What is the ratio of the Imports(as % of merchandise exports) of Thailand in 1996 to that in 2006?
Keep it short and to the point. 1.15. What is the ratio of the Imports(as % of merchandise exports) in Guinea in 1997 to that in 1998?
Provide a succinct answer. 1.01. What is the ratio of the Imports(as % of merchandise exports) in Nigeria in 1997 to that in 1998?
Your response must be concise. 1.01. What is the ratio of the Imports(as % of merchandise exports) of Seychelles in 1997 to that in 1998?
Ensure brevity in your answer.  0.88. What is the ratio of the Imports(as % of merchandise exports) of Guinea in 1997 to that in 1999?
Ensure brevity in your answer.  1.09. What is the ratio of the Imports(as % of merchandise exports) of Nigeria in 1997 to that in 1999?
Your response must be concise. 1.13. What is the ratio of the Imports(as % of merchandise exports) in Seychelles in 1997 to that in 1999?
Give a very brief answer. 0.86. What is the ratio of the Imports(as % of merchandise exports) of Thailand in 1997 to that in 1999?
Ensure brevity in your answer.  1. What is the ratio of the Imports(as % of merchandise exports) of Guinea in 1997 to that in 2000?
Offer a terse response. 1.32. What is the ratio of the Imports(as % of merchandise exports) in Nigeria in 1997 to that in 2000?
Offer a very short reply. 1. What is the ratio of the Imports(as % of merchandise exports) in Seychelles in 1997 to that in 2000?
Ensure brevity in your answer.  1.22. What is the ratio of the Imports(as % of merchandise exports) in Thailand in 1997 to that in 2000?
Ensure brevity in your answer.  1.02. What is the ratio of the Imports(as % of merchandise exports) in Guinea in 1997 to that in 2001?
Your answer should be compact. 1.14. What is the ratio of the Imports(as % of merchandise exports) of Nigeria in 1997 to that in 2001?
Keep it short and to the point. 1.06. What is the ratio of the Imports(as % of merchandise exports) in Seychelles in 1997 to that in 2001?
Your answer should be very brief. 0.86. What is the ratio of the Imports(as % of merchandise exports) in Thailand in 1997 to that in 2001?
Offer a very short reply. 1.02. What is the ratio of the Imports(as % of merchandise exports) of Guinea in 1997 to that in 2002?
Ensure brevity in your answer.  1.21. What is the ratio of the Imports(as % of merchandise exports) in Nigeria in 1997 to that in 2002?
Ensure brevity in your answer.  0.99. What is the ratio of the Imports(as % of merchandise exports) in Seychelles in 1997 to that in 2002?
Give a very brief answer. 1.07. What is the ratio of the Imports(as % of merchandise exports) in Thailand in 1997 to that in 2002?
Give a very brief answer. 1.02. What is the ratio of the Imports(as % of merchandise exports) of Guinea in 1997 to that in 2006?
Ensure brevity in your answer.  1.31. What is the ratio of the Imports(as % of merchandise exports) of Nigeria in 1997 to that in 2006?
Your answer should be very brief. 1.05. What is the ratio of the Imports(as % of merchandise exports) of Seychelles in 1997 to that in 2006?
Provide a short and direct response. 1.41. What is the ratio of the Imports(as % of merchandise exports) of Thailand in 1997 to that in 2006?
Offer a terse response. 1.14. What is the ratio of the Imports(as % of merchandise exports) of Guinea in 1998 to that in 1999?
Keep it short and to the point. 1.07. What is the ratio of the Imports(as % of merchandise exports) of Nigeria in 1998 to that in 1999?
Give a very brief answer. 1.12. What is the ratio of the Imports(as % of merchandise exports) of Thailand in 1998 to that in 1999?
Offer a terse response. 1. What is the ratio of the Imports(as % of merchandise exports) of Guinea in 1998 to that in 2000?
Give a very brief answer. 1.3. What is the ratio of the Imports(as % of merchandise exports) of Nigeria in 1998 to that in 2000?
Offer a terse response. 0.99. What is the ratio of the Imports(as % of merchandise exports) in Seychelles in 1998 to that in 2000?
Your answer should be compact. 1.39. What is the ratio of the Imports(as % of merchandise exports) of Thailand in 1998 to that in 2000?
Give a very brief answer. 1.02. What is the ratio of the Imports(as % of merchandise exports) in Guinea in 1998 to that in 2001?
Give a very brief answer. 1.13. What is the ratio of the Imports(as % of merchandise exports) of Nigeria in 1998 to that in 2001?
Your answer should be compact. 1.05. What is the ratio of the Imports(as % of merchandise exports) of Seychelles in 1998 to that in 2001?
Keep it short and to the point. 0.99. What is the ratio of the Imports(as % of merchandise exports) of Thailand in 1998 to that in 2001?
Keep it short and to the point. 1.03. What is the ratio of the Imports(as % of merchandise exports) of Guinea in 1998 to that in 2002?
Keep it short and to the point. 1.19. What is the ratio of the Imports(as % of merchandise exports) in Nigeria in 1998 to that in 2002?
Give a very brief answer. 0.98. What is the ratio of the Imports(as % of merchandise exports) of Seychelles in 1998 to that in 2002?
Keep it short and to the point. 1.22. What is the ratio of the Imports(as % of merchandise exports) of Thailand in 1998 to that in 2002?
Offer a very short reply. 1.02. What is the ratio of the Imports(as % of merchandise exports) in Guinea in 1998 to that in 2006?
Your answer should be compact. 1.3. What is the ratio of the Imports(as % of merchandise exports) of Nigeria in 1998 to that in 2006?
Your response must be concise. 1.04. What is the ratio of the Imports(as % of merchandise exports) of Seychelles in 1998 to that in 2006?
Make the answer very short. 1.61. What is the ratio of the Imports(as % of merchandise exports) in Thailand in 1998 to that in 2006?
Offer a very short reply. 1.15. What is the ratio of the Imports(as % of merchandise exports) in Guinea in 1999 to that in 2000?
Give a very brief answer. 1.21. What is the ratio of the Imports(as % of merchandise exports) in Nigeria in 1999 to that in 2000?
Ensure brevity in your answer.  0.89. What is the ratio of the Imports(as % of merchandise exports) of Seychelles in 1999 to that in 2000?
Provide a succinct answer. 1.41. What is the ratio of the Imports(as % of merchandise exports) in Thailand in 1999 to that in 2000?
Provide a short and direct response. 1.01. What is the ratio of the Imports(as % of merchandise exports) in Guinea in 1999 to that in 2001?
Provide a succinct answer. 1.05. What is the ratio of the Imports(as % of merchandise exports) of Nigeria in 1999 to that in 2001?
Provide a short and direct response. 0.94. What is the ratio of the Imports(as % of merchandise exports) of Seychelles in 1999 to that in 2001?
Offer a terse response. 1. What is the ratio of the Imports(as % of merchandise exports) of Thailand in 1999 to that in 2001?
Provide a short and direct response. 1.02. What is the ratio of the Imports(as % of merchandise exports) in Guinea in 1999 to that in 2002?
Keep it short and to the point. 1.11. What is the ratio of the Imports(as % of merchandise exports) in Nigeria in 1999 to that in 2002?
Offer a terse response. 0.88. What is the ratio of the Imports(as % of merchandise exports) of Seychelles in 1999 to that in 2002?
Keep it short and to the point. 1.24. What is the ratio of the Imports(as % of merchandise exports) in Thailand in 1999 to that in 2002?
Your answer should be very brief. 1.01. What is the ratio of the Imports(as % of merchandise exports) of Guinea in 1999 to that in 2006?
Your answer should be very brief. 1.21. What is the ratio of the Imports(as % of merchandise exports) in Nigeria in 1999 to that in 2006?
Provide a succinct answer. 0.93. What is the ratio of the Imports(as % of merchandise exports) of Seychelles in 1999 to that in 2006?
Your answer should be compact. 1.63. What is the ratio of the Imports(as % of merchandise exports) in Thailand in 1999 to that in 2006?
Keep it short and to the point. 1.14. What is the ratio of the Imports(as % of merchandise exports) of Guinea in 2000 to that in 2001?
Give a very brief answer. 0.87. What is the ratio of the Imports(as % of merchandise exports) in Nigeria in 2000 to that in 2001?
Offer a terse response. 1.06. What is the ratio of the Imports(as % of merchandise exports) in Seychelles in 2000 to that in 2001?
Offer a terse response. 0.71. What is the ratio of the Imports(as % of merchandise exports) of Thailand in 2000 to that in 2001?
Your response must be concise. 1.01. What is the ratio of the Imports(as % of merchandise exports) in Guinea in 2000 to that in 2002?
Offer a terse response. 0.92. What is the ratio of the Imports(as % of merchandise exports) of Nigeria in 2000 to that in 2002?
Ensure brevity in your answer.  0.99. What is the ratio of the Imports(as % of merchandise exports) in Seychelles in 2000 to that in 2002?
Your answer should be compact. 0.88. What is the ratio of the Imports(as % of merchandise exports) of Thailand in 2000 to that in 2002?
Ensure brevity in your answer.  1. What is the ratio of the Imports(as % of merchandise exports) of Nigeria in 2000 to that in 2006?
Give a very brief answer. 1.04. What is the ratio of the Imports(as % of merchandise exports) in Seychelles in 2000 to that in 2006?
Make the answer very short. 1.16. What is the ratio of the Imports(as % of merchandise exports) of Thailand in 2000 to that in 2006?
Your response must be concise. 1.12. What is the ratio of the Imports(as % of merchandise exports) in Guinea in 2001 to that in 2002?
Your response must be concise. 1.06. What is the ratio of the Imports(as % of merchandise exports) in Nigeria in 2001 to that in 2002?
Give a very brief answer. 0.94. What is the ratio of the Imports(as % of merchandise exports) of Seychelles in 2001 to that in 2002?
Offer a very short reply. 1.24. What is the ratio of the Imports(as % of merchandise exports) in Guinea in 2001 to that in 2006?
Make the answer very short. 1.15. What is the ratio of the Imports(as % of merchandise exports) of Nigeria in 2001 to that in 2006?
Offer a terse response. 0.99. What is the ratio of the Imports(as % of merchandise exports) in Seychelles in 2001 to that in 2006?
Offer a very short reply. 1.63. What is the ratio of the Imports(as % of merchandise exports) of Thailand in 2001 to that in 2006?
Your response must be concise. 1.11. What is the ratio of the Imports(as % of merchandise exports) in Guinea in 2002 to that in 2006?
Keep it short and to the point. 1.09. What is the ratio of the Imports(as % of merchandise exports) of Nigeria in 2002 to that in 2006?
Keep it short and to the point. 1.06. What is the ratio of the Imports(as % of merchandise exports) of Seychelles in 2002 to that in 2006?
Provide a succinct answer. 1.32. What is the ratio of the Imports(as % of merchandise exports) of Thailand in 2002 to that in 2006?
Your answer should be compact. 1.12. What is the difference between the highest and the second highest Imports(as % of merchandise exports) in Guinea?
Your answer should be compact. 0.94. What is the difference between the highest and the second highest Imports(as % of merchandise exports) in Nigeria?
Your answer should be compact. 1.39. What is the difference between the highest and the second highest Imports(as % of merchandise exports) of Seychelles?
Your answer should be very brief. 8.65. What is the difference between the highest and the second highest Imports(as % of merchandise exports) of Thailand?
Your answer should be compact. 0.23. What is the difference between the highest and the lowest Imports(as % of merchandise exports) of Guinea?
Give a very brief answer. 15.34. What is the difference between the highest and the lowest Imports(as % of merchandise exports) of Nigeria?
Provide a short and direct response. 10.66. What is the difference between the highest and the lowest Imports(as % of merchandise exports) of Seychelles?
Keep it short and to the point. 34.28. What is the difference between the highest and the lowest Imports(as % of merchandise exports) of Thailand?
Ensure brevity in your answer.  10.16. 